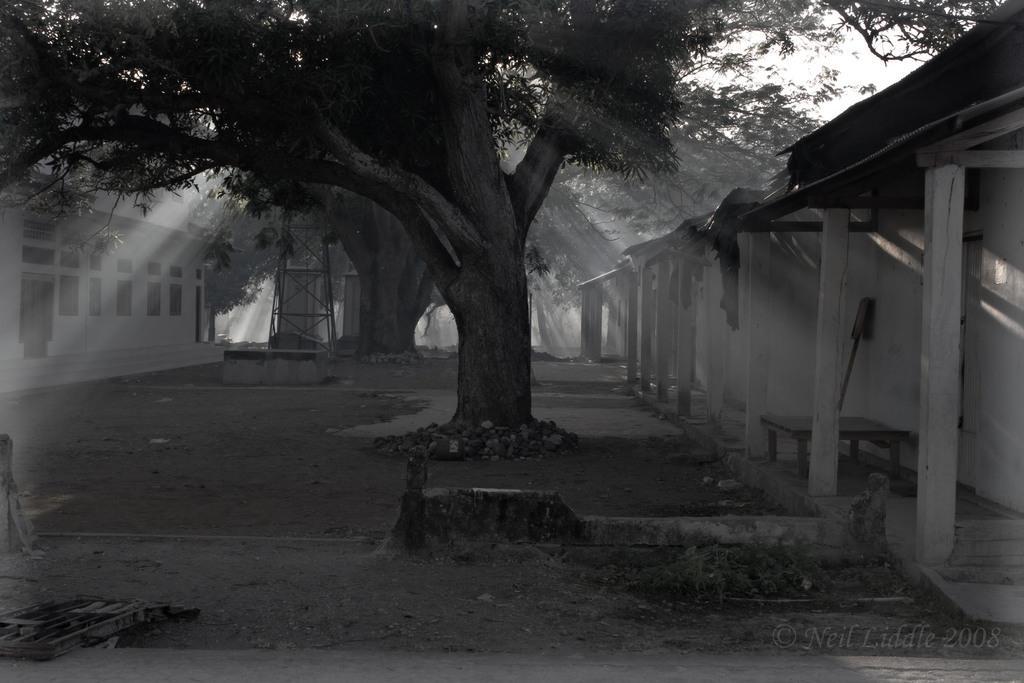Could you give a brief overview of what you see in this image? This is a black and white picture. In this picture we can see a house, windows, trees. On the right side of the picture we can see the walls, pillars and roof top is visible. In this picture we can see a bed frame, pebbles and few objects. 